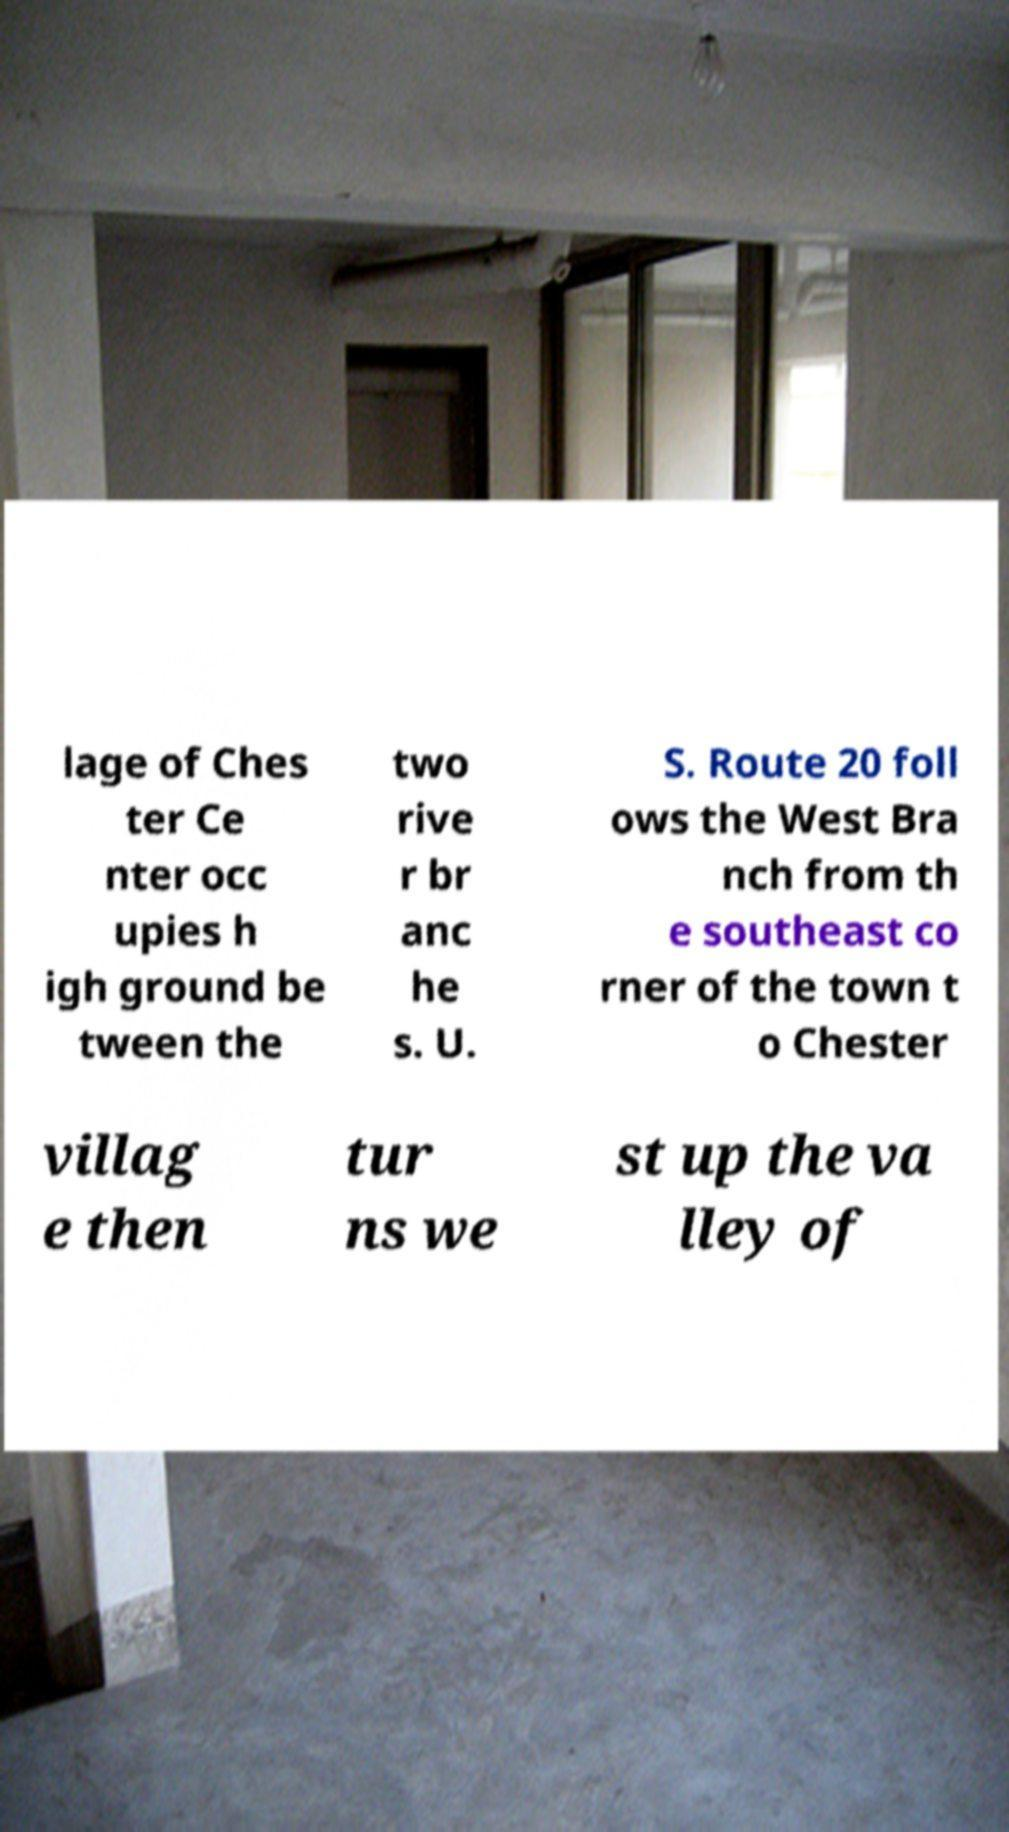Could you extract and type out the text from this image? lage of Ches ter Ce nter occ upies h igh ground be tween the two rive r br anc he s. U. S. Route 20 foll ows the West Bra nch from th e southeast co rner of the town t o Chester villag e then tur ns we st up the va lley of 